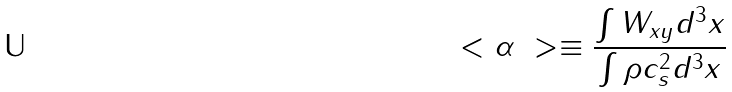Convert formula to latex. <formula><loc_0><loc_0><loc_500><loc_500>\ < \alpha \ > \equiv \frac { \int W _ { x y } d ^ { 3 } x } { \int \rho c _ { s } ^ { 2 } d ^ { 3 } x }</formula> 